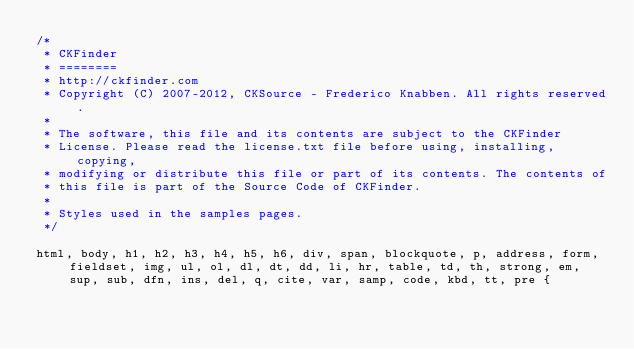<code> <loc_0><loc_0><loc_500><loc_500><_CSS_>/*
 * CKFinder
 * ========
 * http://ckfinder.com
 * Copyright (C) 2007-2012, CKSource - Frederico Knabben. All rights reserved.
 *
 * The software, this file and its contents are subject to the CKFinder
 * License. Please read the license.txt file before using, installing, copying,
 * modifying or distribute this file or part of its contents. The contents of
 * this file is part of the Source Code of CKFinder.
 *
 * Styles used in the samples pages.
 */

html, body, h1, h2, h3, h4, h5, h6, div, span, blockquote, p, address, form, fieldset, img, ul, ol, dl, dt, dd, li, hr, table, td, th, strong, em, sup, sub, dfn, ins, del, q, cite, var, samp, code, kbd, tt, pre {</code> 